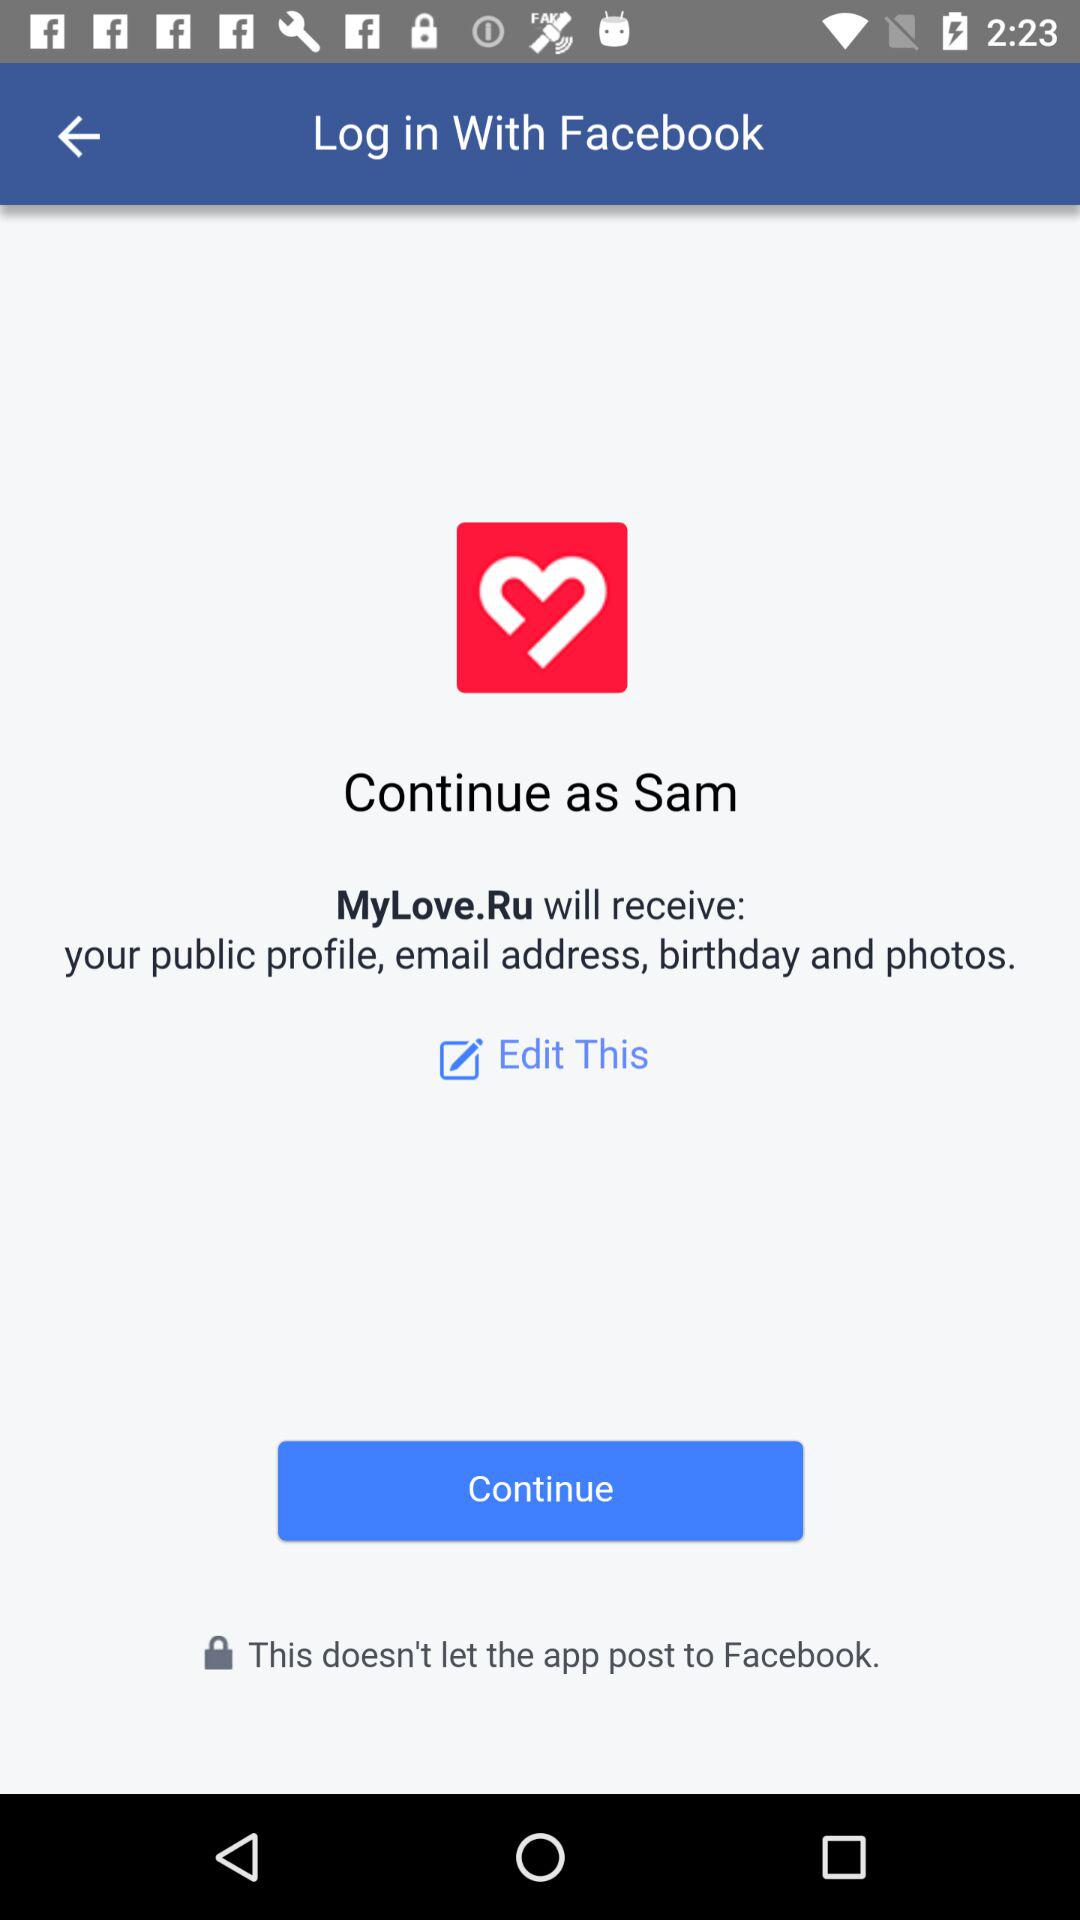What application will receive my public profile, email address, birthday and photos? The application is "MyLove.Ru". 